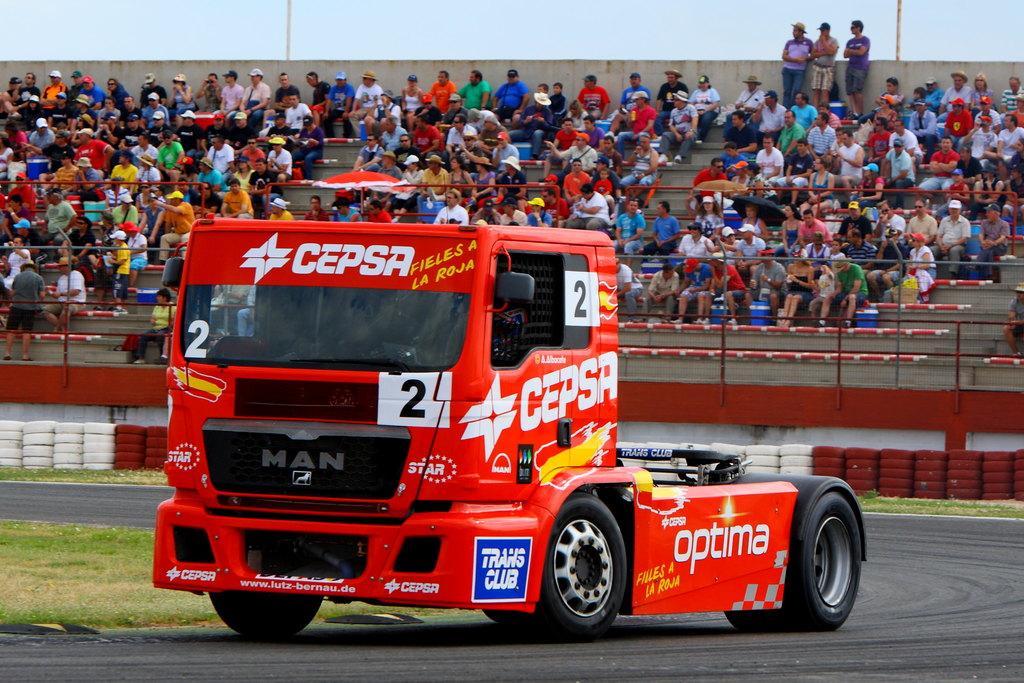How would you summarize this image in a sentence or two? In this picture I can see a red color truck in front and I can see few words and numbers written on it. In the middle of this picture I can see the grass and the tires. In the background I can see the fencing and number of people sitting and I see 3 men on the right who are standing and I see the sky. 